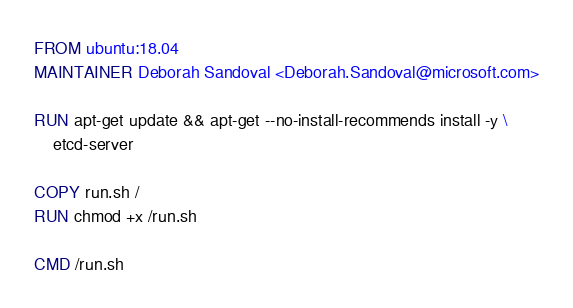<code> <loc_0><loc_0><loc_500><loc_500><_Dockerfile_>FROM ubuntu:18.04
MAINTAINER Deborah Sandoval <Deborah.Sandoval@microsoft.com>

RUN apt-get update && apt-get --no-install-recommends install -y \
    etcd-server

COPY run.sh /
RUN chmod +x /run.sh

CMD /run.sh
</code> 